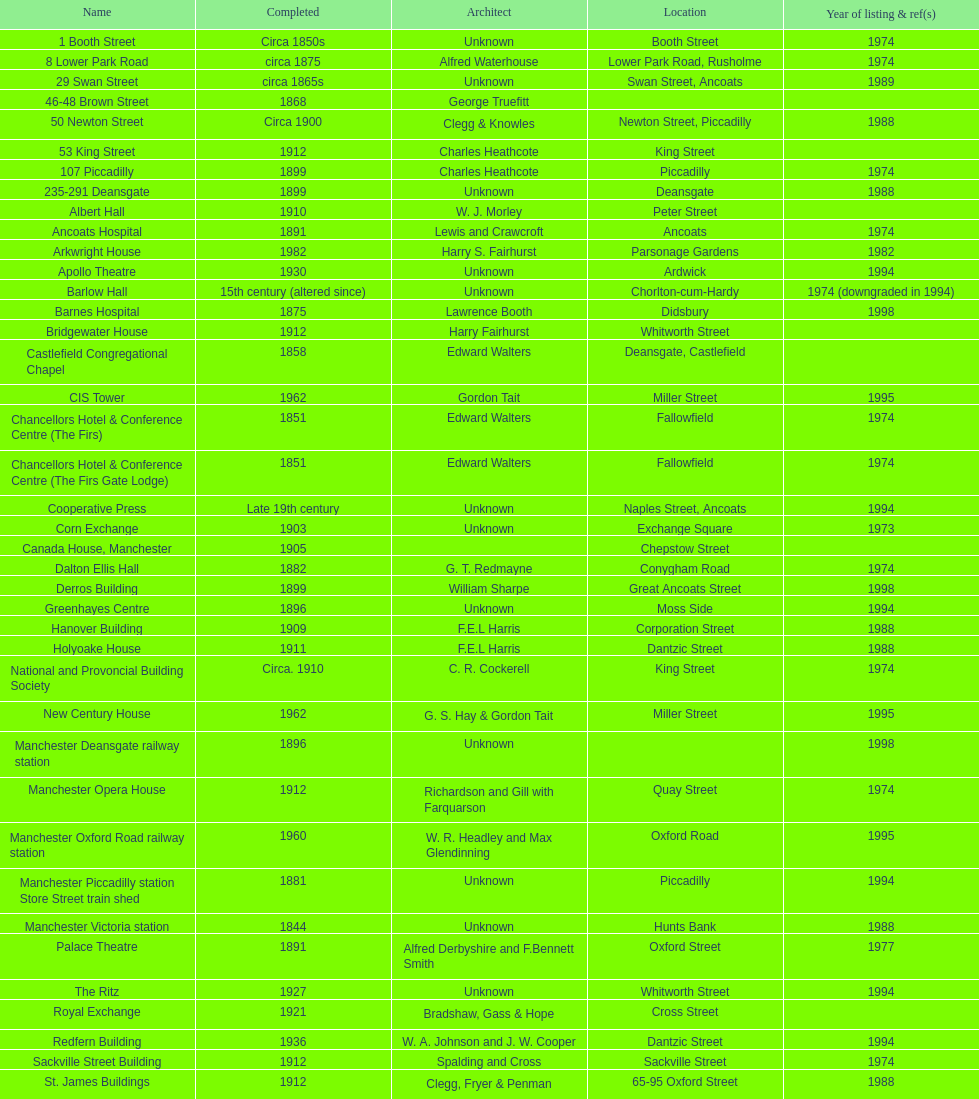How many buildings do not have an image listed? 11. 